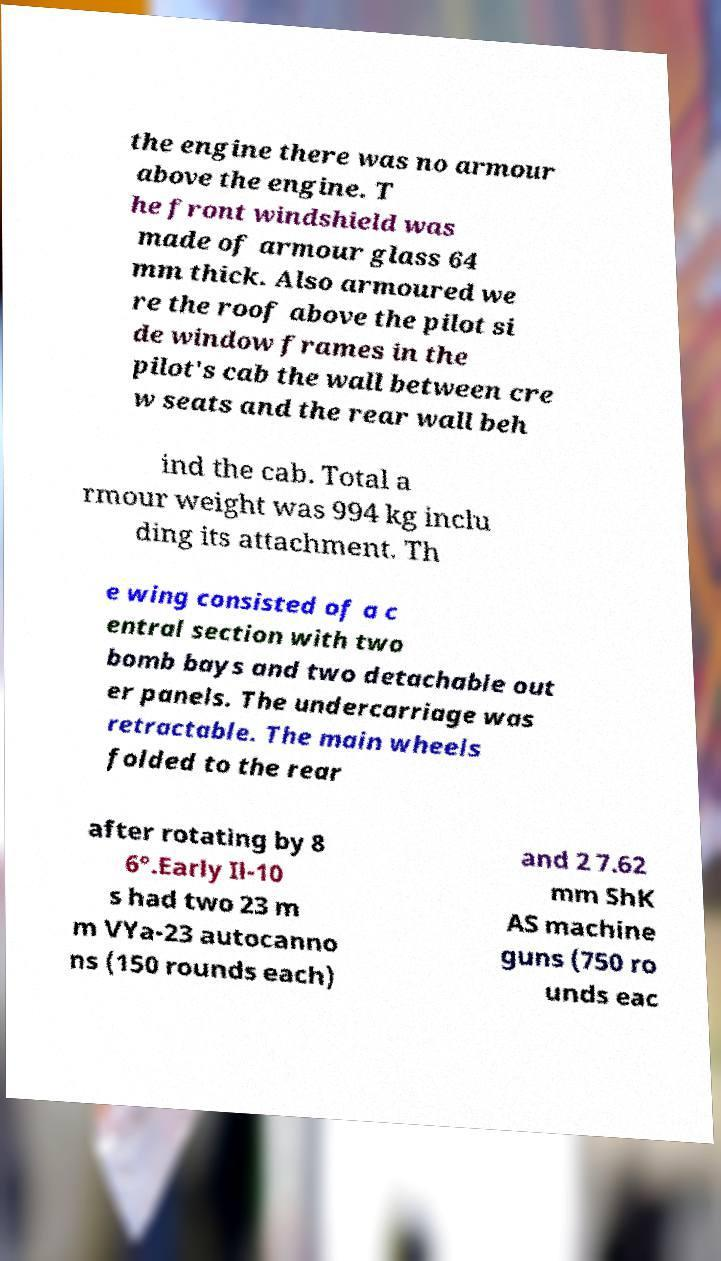There's text embedded in this image that I need extracted. Can you transcribe it verbatim? the engine there was no armour above the engine. T he front windshield was made of armour glass 64 mm thick. Also armoured we re the roof above the pilot si de window frames in the pilot's cab the wall between cre w seats and the rear wall beh ind the cab. Total a rmour weight was 994 kg inclu ding its attachment. Th e wing consisted of a c entral section with two bomb bays and two detachable out er panels. The undercarriage was retractable. The main wheels folded to the rear after rotating by 8 6°.Early Il-10 s had two 23 m m VYa-23 autocanno ns (150 rounds each) and 2 7.62 mm ShK AS machine guns (750 ro unds eac 